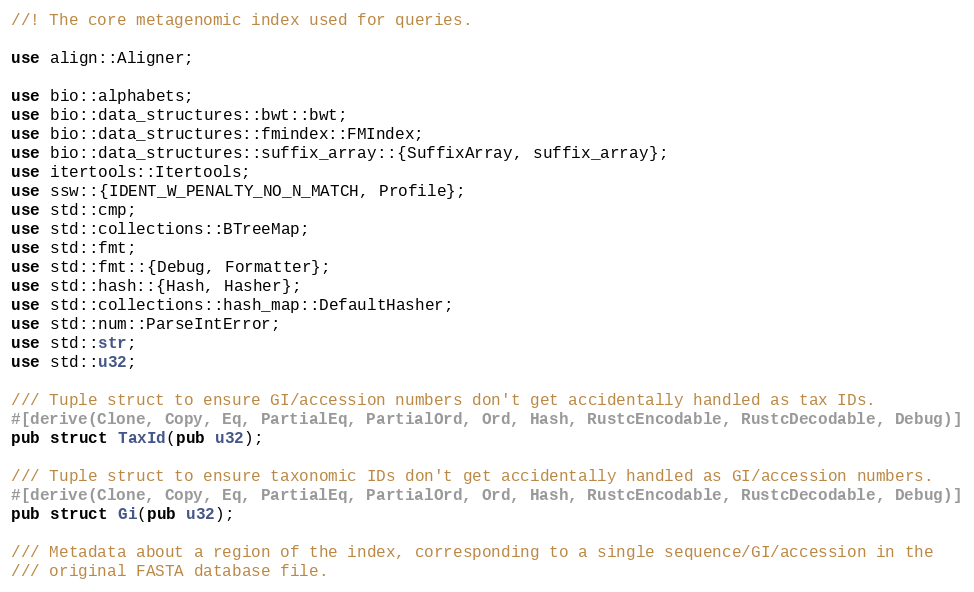<code> <loc_0><loc_0><loc_500><loc_500><_Rust_>//! The core metagenomic index used for queries.

use align::Aligner;

use bio::alphabets;
use bio::data_structures::bwt::bwt;
use bio::data_structures::fmindex::FMIndex;
use bio::data_structures::suffix_array::{SuffixArray, suffix_array};
use itertools::Itertools;
use ssw::{IDENT_W_PENALTY_NO_N_MATCH, Profile};
use std::cmp;
use std::collections::BTreeMap;
use std::fmt;
use std::fmt::{Debug, Formatter};
use std::hash::{Hash, Hasher};
use std::collections::hash_map::DefaultHasher;
use std::num::ParseIntError;
use std::str;
use std::u32;

/// Tuple struct to ensure GI/accession numbers don't get accidentally handled as tax IDs.
#[derive(Clone, Copy, Eq, PartialEq, PartialOrd, Ord, Hash, RustcEncodable, RustcDecodable, Debug)]
pub struct TaxId(pub u32);

/// Tuple struct to ensure taxonomic IDs don't get accidentally handled as GI/accession numbers.
#[derive(Clone, Copy, Eq, PartialEq, PartialOrd, Ord, Hash, RustcEncodable, RustcDecodable, Debug)]
pub struct Gi(pub u32);

/// Metadata about a region of the index, corresponding to a single sequence/GI/accession in the
/// original FASTA database file.</code> 